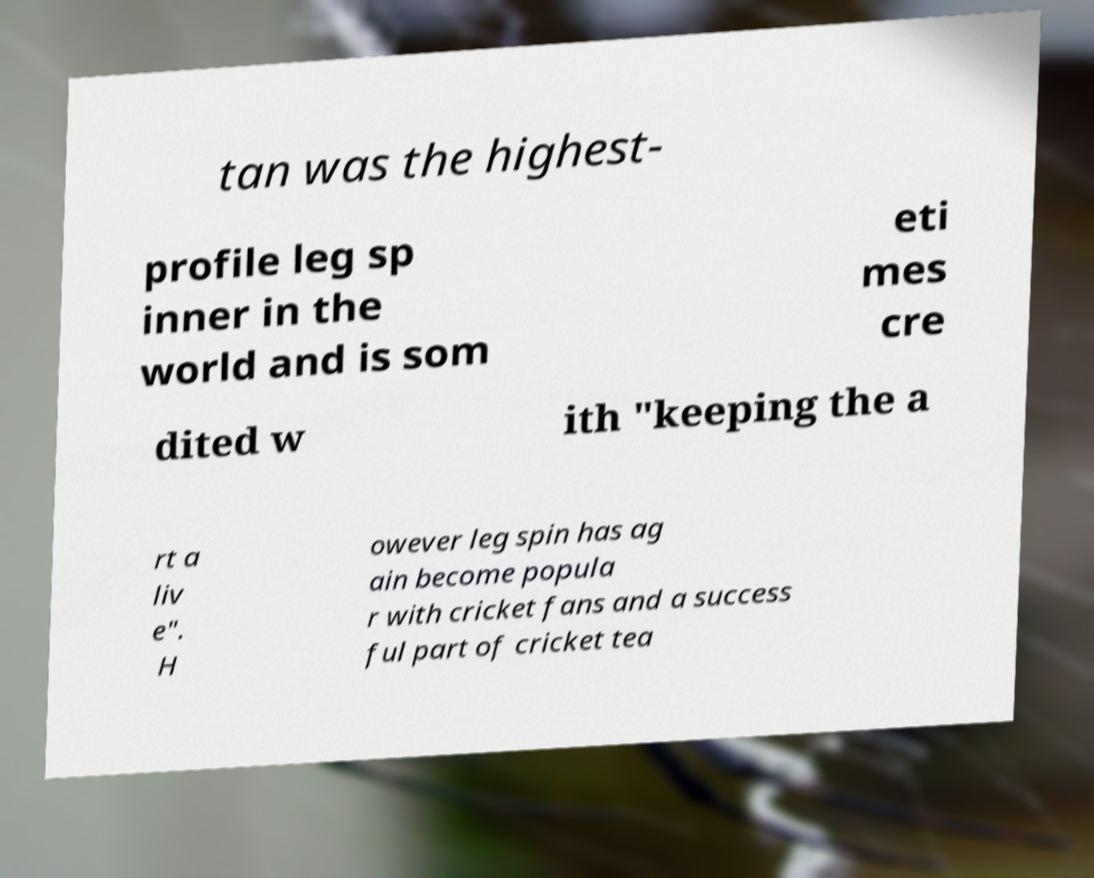Could you extract and type out the text from this image? tan was the highest- profile leg sp inner in the world and is som eti mes cre dited w ith "keeping the a rt a liv e". H owever leg spin has ag ain become popula r with cricket fans and a success ful part of cricket tea 